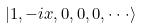<formula> <loc_0><loc_0><loc_500><loc_500>| 1 , - i x , 0 , 0 , 0 , \cdot \cdot \cdot \rangle</formula> 